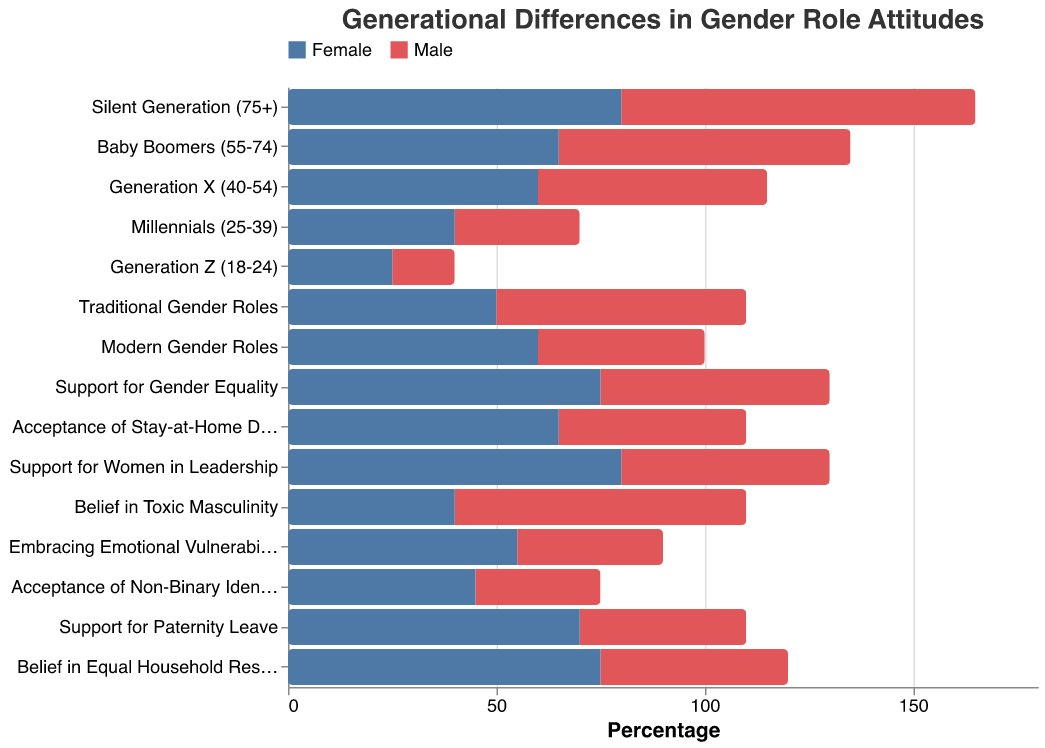What is the title of the figure? The title of the figure is displayed at the top and reads "Generational Differences in Gender Role Attitudes". This can be directly observed from the visible text at the top of the chart.
Answer: Generational Differences in Gender Role Attitudes What colors are used to represent male and female attitudes in the figure? The colors are shown in the legend at the top of the figure, where blue represents male attitudes and red represents female attitudes.
Answer: Blue and Red Which age group shows the highest female support for women in leadership? By looking at the data points for each age group and identifying the highest positive value for support for women in leadership, we find it corresponds to the female value of 80, which belongs to the Silent Generation (75+).
Answer: Silent Generation (75+) How does acceptance of stay-at-home dads compare between males and females? To compare, we look at the two data points for acceptance of stay-at-home dads, showing -45 for males and 65 for females.
Answer: Females have higher acceptance than males What is the difference in belief in equal household responsibilities between males and females? The belief in equal household responsibilities data points are -45 for males and 75 for females. The difference is calculated by the difference of these two values.
Answer: 120 Which gender shows more support for modern gender roles? The figure shows support for modern gender roles as -40 for males and 60 for females.
Answer: Females What is the average value of support for gender equality across both genders? Summing the values for support for gender equality gives -55 (male) + 75 (female) = 20. Taking the average of these values: 20/2 = 10.
Answer: 10 Among Generation Z, which gender is more accepting of non-binary identities? The value for acceptance of non-binary identities for males in Generation Z is -30 and for females is 45.
Answer: Females What is the sum of male support for traditional and modern gender roles? Summing the values for male support for traditional (-60) and modern (-40) gender roles: -60 + -40 = -100.
Answer: -100 